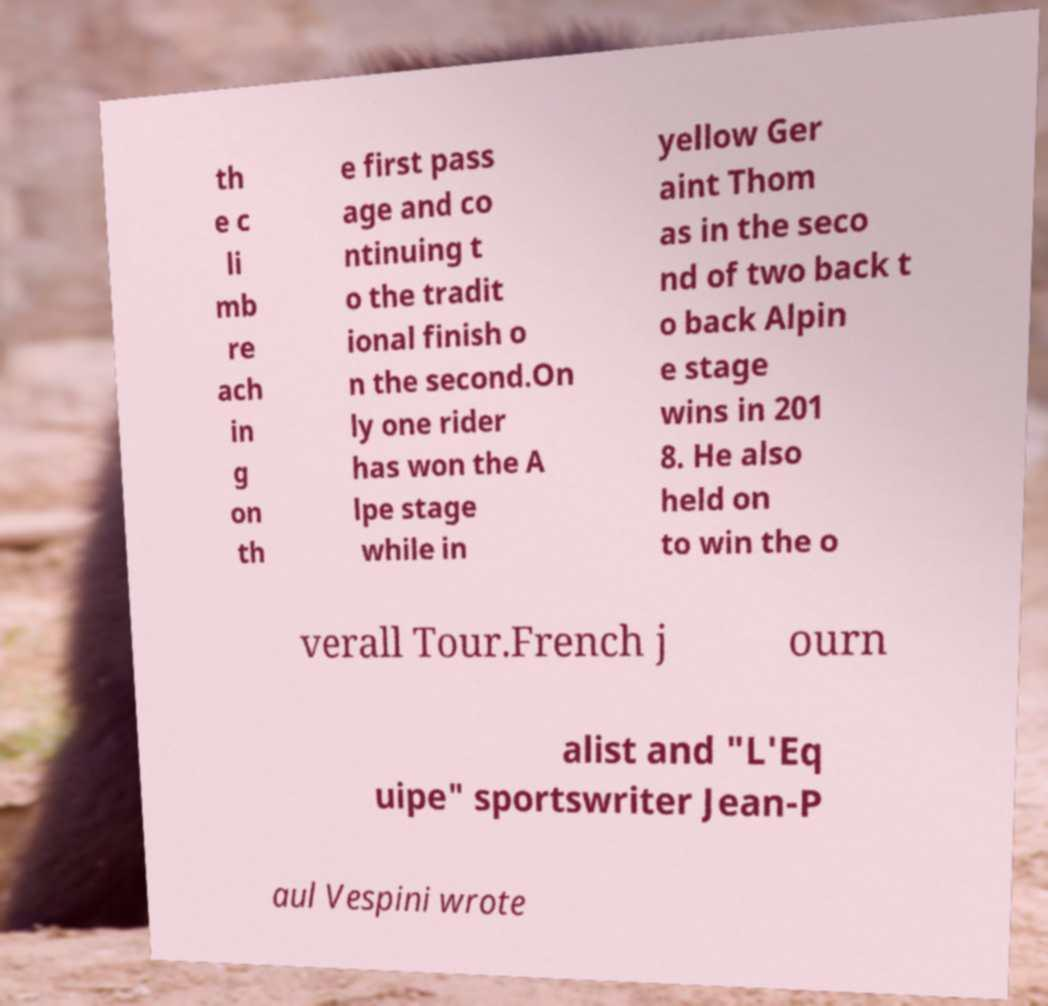Please read and relay the text visible in this image. What does it say? th e c li mb re ach in g on th e first pass age and co ntinuing t o the tradit ional finish o n the second.On ly one rider has won the A lpe stage while in yellow Ger aint Thom as in the seco nd of two back t o back Alpin e stage wins in 201 8. He also held on to win the o verall Tour.French j ourn alist and "L'Eq uipe" sportswriter Jean-P aul Vespini wrote 